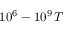Convert formula to latex. <formula><loc_0><loc_0><loc_500><loc_500>1 0 ^ { 6 } - 1 0 ^ { 9 } \, T</formula> 